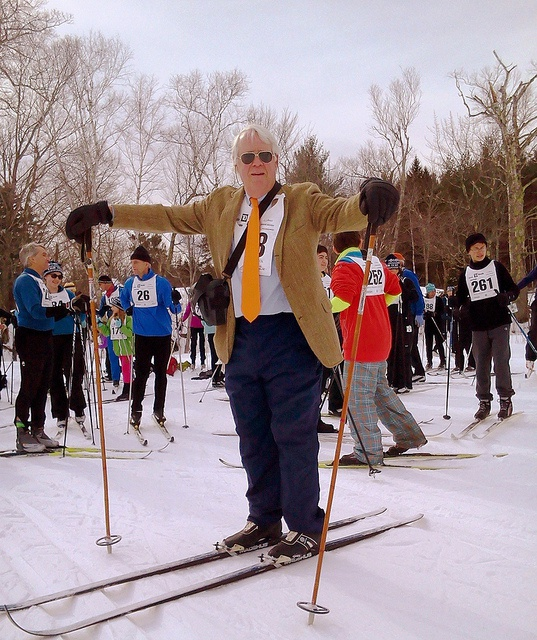Describe the objects in this image and their specific colors. I can see people in gray, black, and brown tones, people in gray and brown tones, people in gray, black, lavender, maroon, and darkgray tones, people in gray, black, and navy tones, and skis in gray, lavender, darkgray, black, and lightgray tones in this image. 